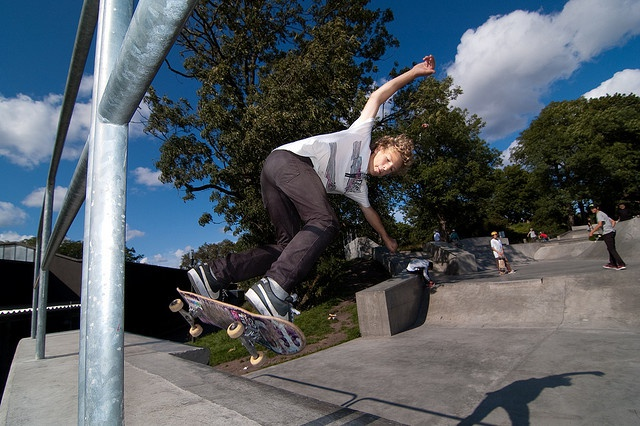Describe the objects in this image and their specific colors. I can see people in blue, black, gray, lightgray, and darkgray tones, skateboard in blue, gray, black, and darkgray tones, people in blue, black, gray, darkgray, and brown tones, people in blue, black, gray, and darkgray tones, and people in blue, black, gray, lightgray, and darkgray tones in this image. 